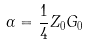Convert formula to latex. <formula><loc_0><loc_0><loc_500><loc_500>\alpha = \frac { 1 } { 4 } Z _ { 0 } G _ { 0 }</formula> 